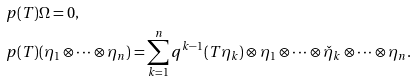Convert formula to latex. <formula><loc_0><loc_0><loc_500><loc_500>& p ( T ) \Omega = 0 , \\ & p ( T ) ( \eta _ { 1 } \otimes \dots \otimes \eta _ { n } ) = \sum _ { k = 1 } ^ { n } q ^ { k - 1 } ( T \eta _ { k } ) \otimes \eta _ { 1 } \otimes \dots \otimes \check { \eta } _ { k } \otimes \dots \otimes \eta _ { n } .</formula> 